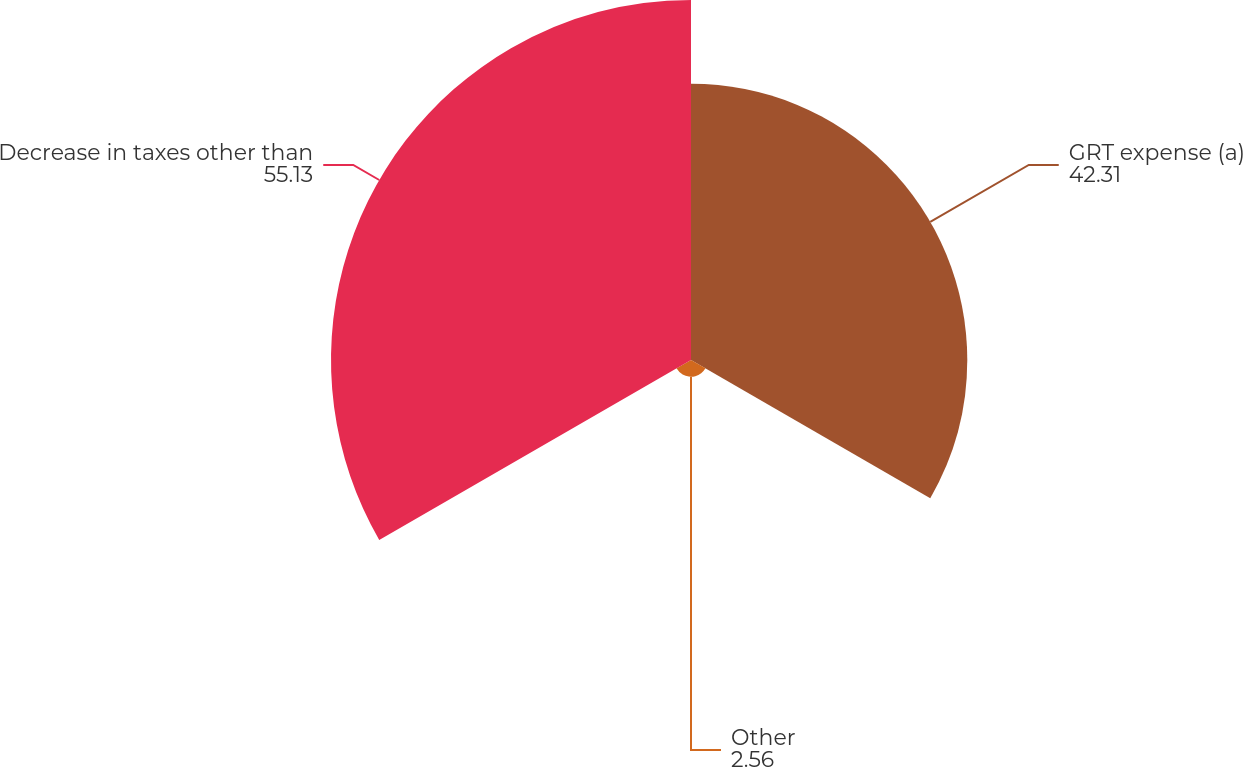Convert chart. <chart><loc_0><loc_0><loc_500><loc_500><pie_chart><fcel>GRT expense (a)<fcel>Other<fcel>Decrease in taxes other than<nl><fcel>42.31%<fcel>2.56%<fcel>55.13%<nl></chart> 